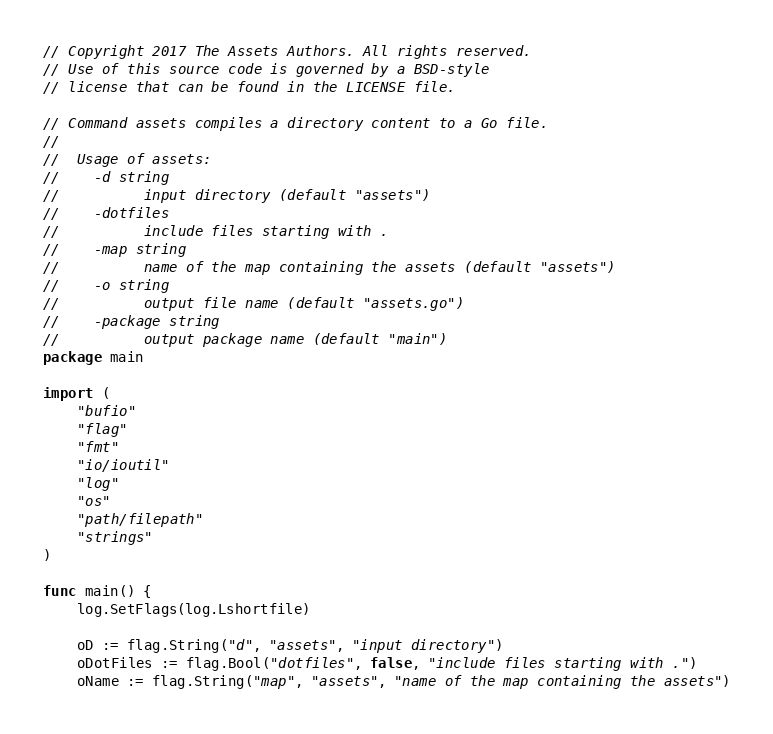<code> <loc_0><loc_0><loc_500><loc_500><_Go_>// Copyright 2017 The Assets Authors. All rights reserved.
// Use of this source code is governed by a BSD-style
// license that can be found in the LICENSE file.

// Command assets compiles a directory content to a Go file.
//
//	Usage of assets:
//	  -d string
//	    	input directory (default "assets")
//	  -dotfiles
//	    	include files starting with .
//	  -map string
//	    	name of the map containing the assets (default "assets")
//	  -o string
//	    	output file name (default "assets.go")
//	  -package string
//	    	output package name (default "main")
package main

import (
	"bufio"
	"flag"
	"fmt"
	"io/ioutil"
	"log"
	"os"
	"path/filepath"
	"strings"
)

func main() {
	log.SetFlags(log.Lshortfile)

	oD := flag.String("d", "assets", "input directory")
	oDotFiles := flag.Bool("dotfiles", false, "include files starting with .")
	oName := flag.String("map", "assets", "name of the map containing the assets")</code> 